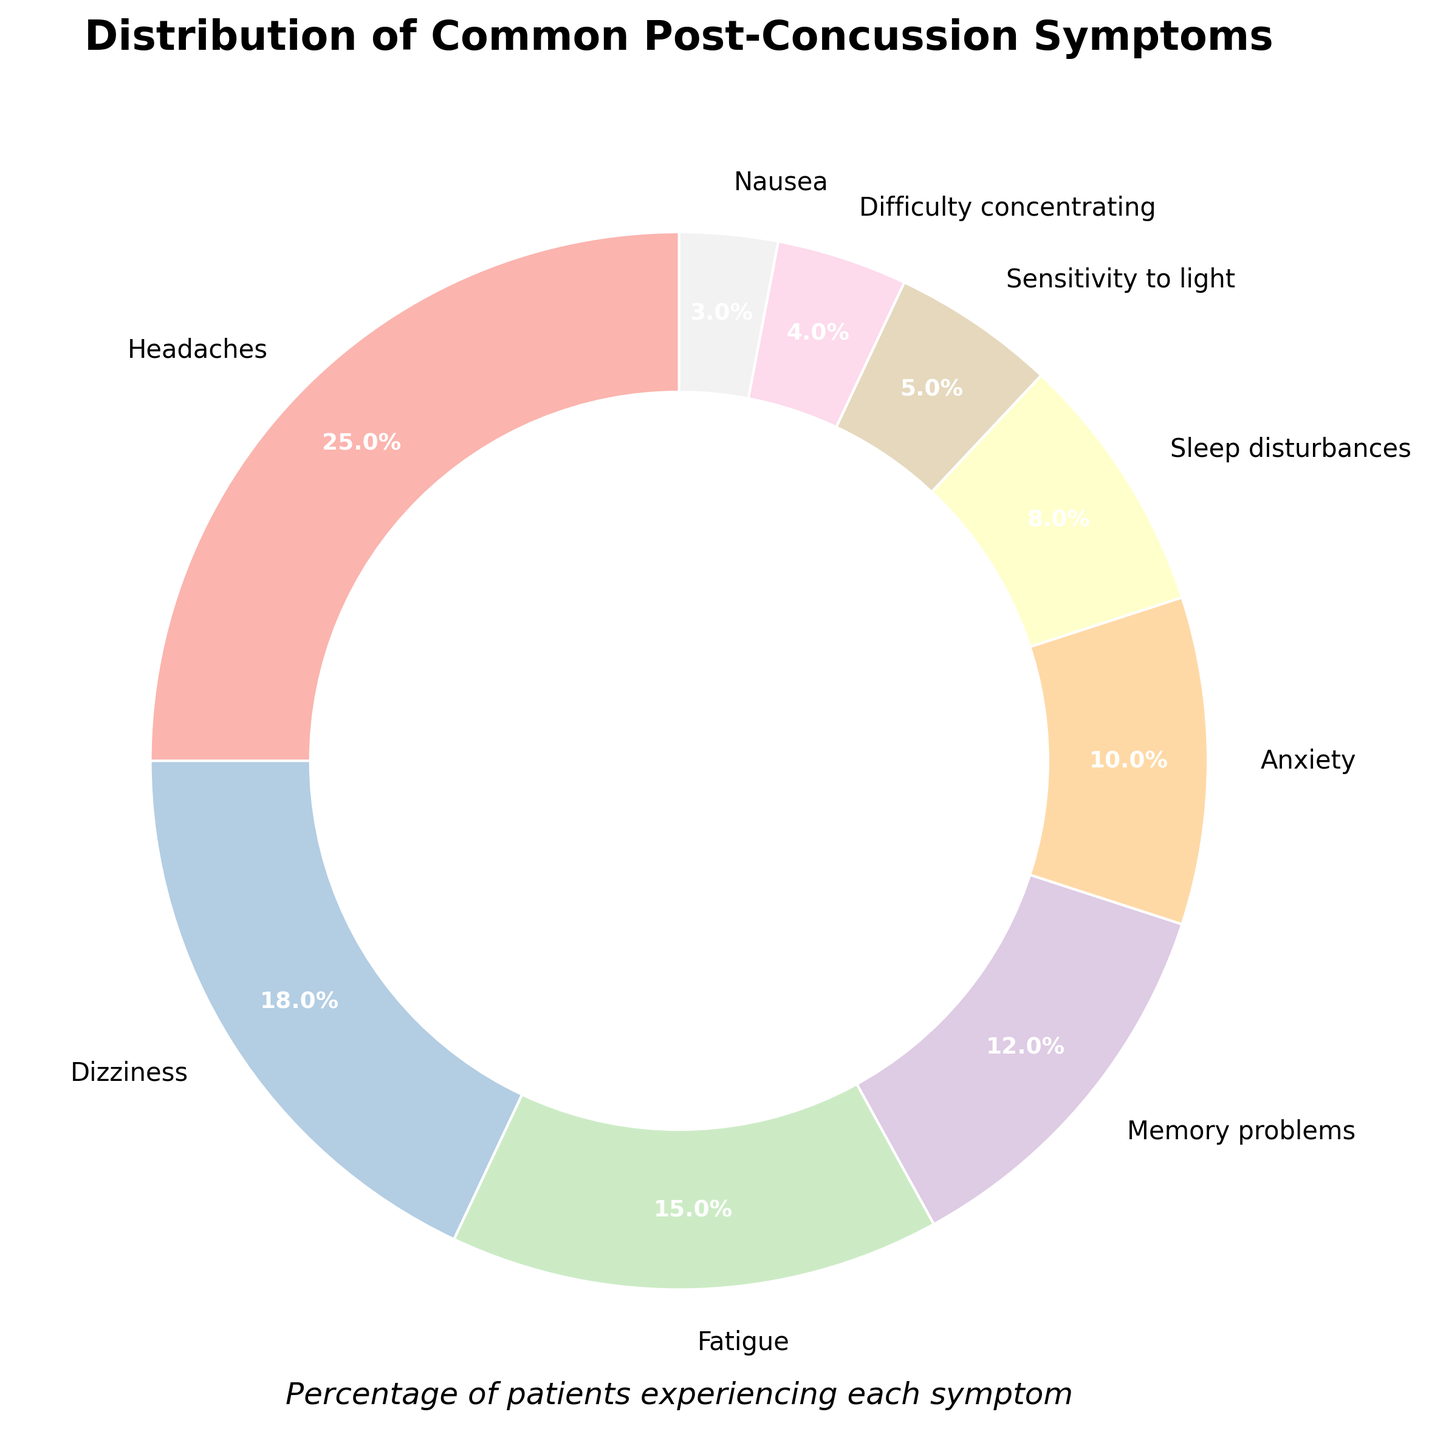What's the most common symptom experienced by patients? The pie chart shows that "Headaches" has the largest wedge, which indicates the highest percentage among all symptoms.
Answer: Headaches Which symptom has the smallest percentage? By looking at the pie chart, "Nausea" has the smallest wedge, indicating it has the lowest percentage.
Answer: Nausea What is the combined percentage of patients experiencing Headaches and Dizziness? Headaches have a percentage of 25%, and Dizziness has 18%. Adding these together gives 25% + 18% = 43%.
Answer: 43% Are there more patients experiencing Fatigue or Memory problems? The wedge for Fatigue is larger than the wedge for Memory problems, indicating that Fatigue has a higher percentage (15%) compared to Memory problems (12%).
Answer: Fatigue How much larger is the percentage of patients experiencing Anxiety than those experiencing Nausea? Anxiety is at 10% and Nausea is at 3%. The difference is 10% - 3% = 7%.
Answer: 7% Is the percentage of patients experiencing Sleep disturbances greater or less than 10%? The pie chart shows the wedge for Sleep disturbances is at 8%, which is less than 10%.
Answer: Less What is the combined percentage of patients experiencing Anxiety, Sleep disturbances, and Sensitivity to light? Anxiety is 10%, Sleep disturbances are 8%, and Sensitivity to light is 5%. Adding these together gives 10% + 8% + 5% = 23%.
Answer: 23% How does the percentage of Difficulty concentrating compare to Sensitivity to light? The pie chart shows that Difficulty concentrating is at 4% and Sensitivity to light is at 5%. Thus, Sensitivity to light is slightly higher.
Answer: Sensitivity to light What percentage of patients do not experience Anxiety, Sleep disturbances, or Sensitivity to light? Using the combined percentage previously calculated as 23%, we subtract this from 100% to find the remaining percentage: 100% - 23% = 77%.
Answer: 77% What is the average percentage of patients experiencing either Dizziness, Fatigue, or Memory problems? The percentages are 18% for Dizziness, 15% for Fatigue, and 12% for Memory problems. The average is calculated as (18% + 15% + 12%) / 3 = 45% / 3 = 15%.
Answer: 15% 